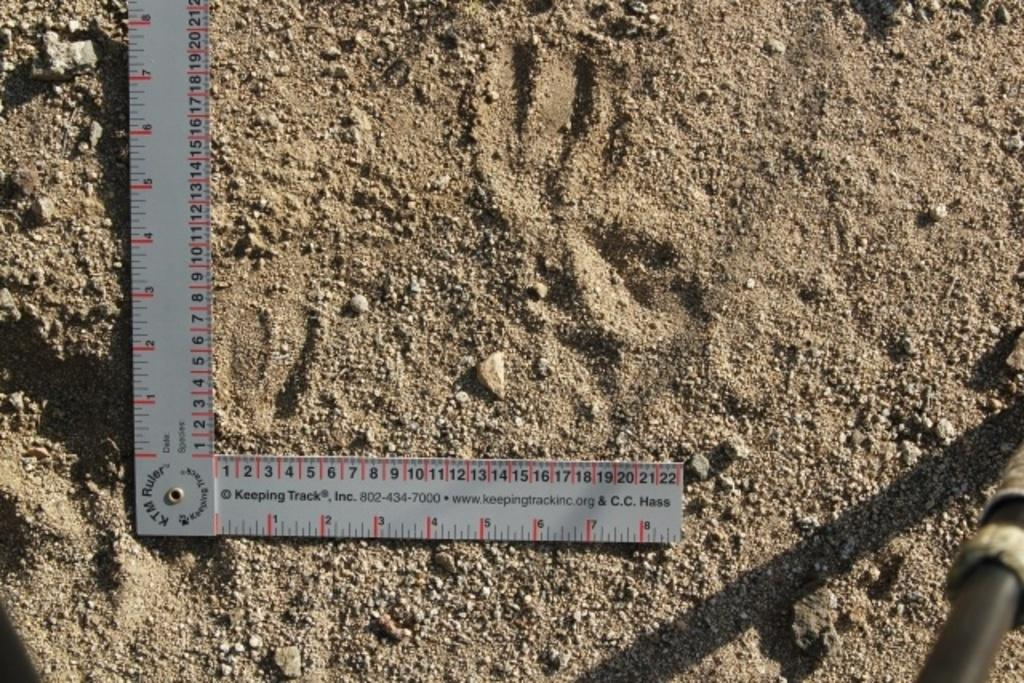<image>
Render a clear and concise summary of the photo. a ruler with keeping track on it under the numbers 